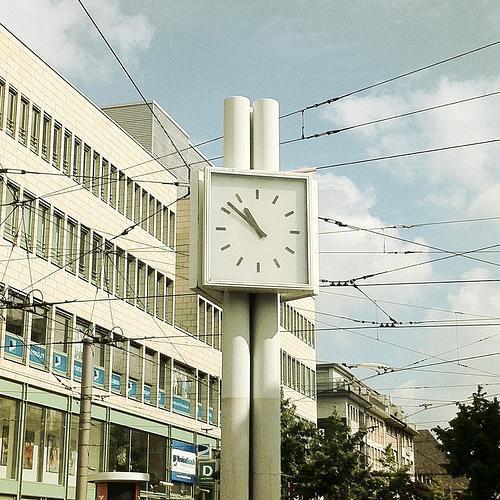How many buildings are there?
Give a very brief answer. 2. 